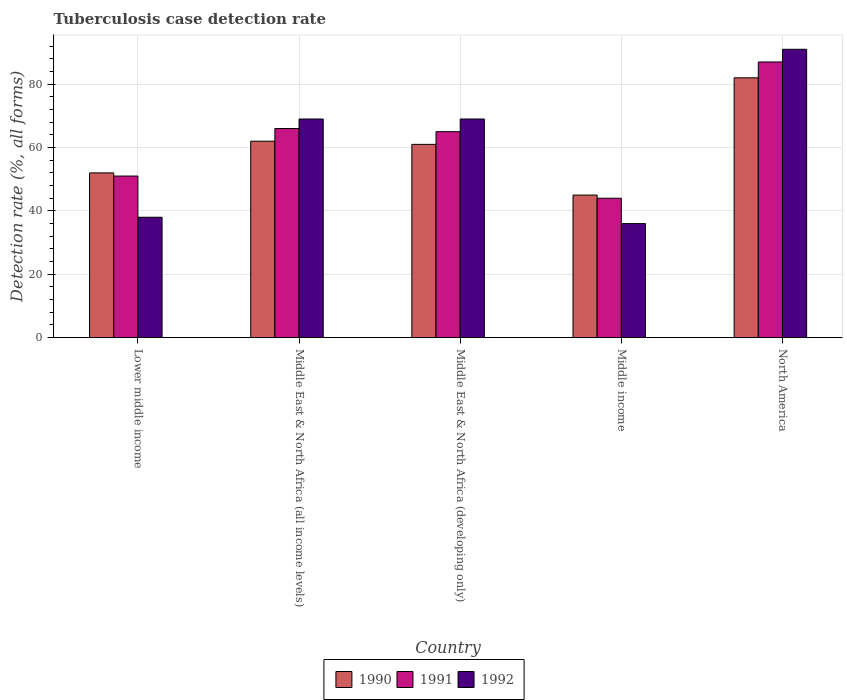How many different coloured bars are there?
Give a very brief answer. 3. How many groups of bars are there?
Your response must be concise. 5. Are the number of bars per tick equal to the number of legend labels?
Keep it short and to the point. Yes. Are the number of bars on each tick of the X-axis equal?
Your answer should be very brief. Yes. What is the label of the 4th group of bars from the left?
Your answer should be compact. Middle income. What is the tuberculosis case detection rate in in 1991 in Middle East & North Africa (all income levels)?
Give a very brief answer. 66. Across all countries, what is the minimum tuberculosis case detection rate in in 1992?
Provide a succinct answer. 36. In which country was the tuberculosis case detection rate in in 1990 minimum?
Your answer should be very brief. Middle income. What is the total tuberculosis case detection rate in in 1991 in the graph?
Provide a short and direct response. 313. What is the difference between the tuberculosis case detection rate in in 1992 in Lower middle income and the tuberculosis case detection rate in in 1990 in North America?
Your answer should be very brief. -44. What is the average tuberculosis case detection rate in in 1990 per country?
Your answer should be very brief. 60.4. In how many countries, is the tuberculosis case detection rate in in 1991 greater than 24 %?
Your answer should be very brief. 5. What is the ratio of the tuberculosis case detection rate in in 1990 in Middle income to that in North America?
Make the answer very short. 0.55. Is the tuberculosis case detection rate in in 1990 in Middle East & North Africa (all income levels) less than that in Middle income?
Keep it short and to the point. No. Is the difference between the tuberculosis case detection rate in in 1991 in Middle income and North America greater than the difference between the tuberculosis case detection rate in in 1990 in Middle income and North America?
Provide a short and direct response. No. What is the difference between the highest and the second highest tuberculosis case detection rate in in 1991?
Provide a short and direct response. -1. In how many countries, is the tuberculosis case detection rate in in 1991 greater than the average tuberculosis case detection rate in in 1991 taken over all countries?
Your answer should be compact. 3. Is it the case that in every country, the sum of the tuberculosis case detection rate in in 1991 and tuberculosis case detection rate in in 1990 is greater than the tuberculosis case detection rate in in 1992?
Offer a very short reply. Yes. How many bars are there?
Make the answer very short. 15. How many countries are there in the graph?
Provide a short and direct response. 5. What is the difference between two consecutive major ticks on the Y-axis?
Offer a very short reply. 20. Does the graph contain any zero values?
Offer a very short reply. No. Does the graph contain grids?
Provide a succinct answer. Yes. Where does the legend appear in the graph?
Give a very brief answer. Bottom center. How are the legend labels stacked?
Offer a terse response. Horizontal. What is the title of the graph?
Provide a short and direct response. Tuberculosis case detection rate. What is the label or title of the Y-axis?
Provide a succinct answer. Detection rate (%, all forms). What is the Detection rate (%, all forms) of 1992 in Lower middle income?
Ensure brevity in your answer.  38. What is the Detection rate (%, all forms) of 1991 in Middle East & North Africa (all income levels)?
Offer a terse response. 66. What is the Detection rate (%, all forms) in 1992 in Middle East & North Africa (developing only)?
Offer a very short reply. 69. What is the Detection rate (%, all forms) in 1991 in Middle income?
Offer a terse response. 44. What is the Detection rate (%, all forms) of 1992 in Middle income?
Provide a short and direct response. 36. What is the Detection rate (%, all forms) of 1991 in North America?
Ensure brevity in your answer.  87. What is the Detection rate (%, all forms) in 1992 in North America?
Provide a short and direct response. 91. Across all countries, what is the maximum Detection rate (%, all forms) in 1991?
Keep it short and to the point. 87. Across all countries, what is the maximum Detection rate (%, all forms) in 1992?
Keep it short and to the point. 91. What is the total Detection rate (%, all forms) of 1990 in the graph?
Provide a short and direct response. 302. What is the total Detection rate (%, all forms) of 1991 in the graph?
Offer a very short reply. 313. What is the total Detection rate (%, all forms) of 1992 in the graph?
Give a very brief answer. 303. What is the difference between the Detection rate (%, all forms) in 1991 in Lower middle income and that in Middle East & North Africa (all income levels)?
Keep it short and to the point. -15. What is the difference between the Detection rate (%, all forms) in 1992 in Lower middle income and that in Middle East & North Africa (all income levels)?
Give a very brief answer. -31. What is the difference between the Detection rate (%, all forms) of 1990 in Lower middle income and that in Middle East & North Africa (developing only)?
Your answer should be compact. -9. What is the difference between the Detection rate (%, all forms) in 1992 in Lower middle income and that in Middle East & North Africa (developing only)?
Make the answer very short. -31. What is the difference between the Detection rate (%, all forms) in 1991 in Lower middle income and that in Middle income?
Offer a very short reply. 7. What is the difference between the Detection rate (%, all forms) of 1991 in Lower middle income and that in North America?
Ensure brevity in your answer.  -36. What is the difference between the Detection rate (%, all forms) in 1992 in Lower middle income and that in North America?
Make the answer very short. -53. What is the difference between the Detection rate (%, all forms) of 1990 in Middle East & North Africa (all income levels) and that in Middle East & North Africa (developing only)?
Make the answer very short. 1. What is the difference between the Detection rate (%, all forms) of 1992 in Middle East & North Africa (all income levels) and that in Middle East & North Africa (developing only)?
Provide a short and direct response. 0. What is the difference between the Detection rate (%, all forms) of 1990 in Middle East & North Africa (developing only) and that in Middle income?
Make the answer very short. 16. What is the difference between the Detection rate (%, all forms) of 1991 in Middle East & North Africa (developing only) and that in Middle income?
Provide a succinct answer. 21. What is the difference between the Detection rate (%, all forms) in 1990 in Middle East & North Africa (developing only) and that in North America?
Provide a short and direct response. -21. What is the difference between the Detection rate (%, all forms) in 1991 in Middle East & North Africa (developing only) and that in North America?
Your answer should be compact. -22. What is the difference between the Detection rate (%, all forms) of 1992 in Middle East & North Africa (developing only) and that in North America?
Give a very brief answer. -22. What is the difference between the Detection rate (%, all forms) in 1990 in Middle income and that in North America?
Offer a terse response. -37. What is the difference between the Detection rate (%, all forms) in 1991 in Middle income and that in North America?
Your answer should be very brief. -43. What is the difference between the Detection rate (%, all forms) in 1992 in Middle income and that in North America?
Give a very brief answer. -55. What is the difference between the Detection rate (%, all forms) of 1990 in Lower middle income and the Detection rate (%, all forms) of 1991 in Middle East & North Africa (all income levels)?
Keep it short and to the point. -14. What is the difference between the Detection rate (%, all forms) of 1991 in Lower middle income and the Detection rate (%, all forms) of 1992 in Middle East & North Africa (all income levels)?
Give a very brief answer. -18. What is the difference between the Detection rate (%, all forms) of 1990 in Lower middle income and the Detection rate (%, all forms) of 1991 in Middle East & North Africa (developing only)?
Offer a terse response. -13. What is the difference between the Detection rate (%, all forms) of 1990 in Lower middle income and the Detection rate (%, all forms) of 1992 in Middle East & North Africa (developing only)?
Offer a terse response. -17. What is the difference between the Detection rate (%, all forms) of 1990 in Lower middle income and the Detection rate (%, all forms) of 1991 in Middle income?
Offer a terse response. 8. What is the difference between the Detection rate (%, all forms) of 1990 in Lower middle income and the Detection rate (%, all forms) of 1991 in North America?
Offer a terse response. -35. What is the difference between the Detection rate (%, all forms) in 1990 in Lower middle income and the Detection rate (%, all forms) in 1992 in North America?
Give a very brief answer. -39. What is the difference between the Detection rate (%, all forms) in 1991 in Lower middle income and the Detection rate (%, all forms) in 1992 in North America?
Your response must be concise. -40. What is the difference between the Detection rate (%, all forms) of 1990 in Middle East & North Africa (all income levels) and the Detection rate (%, all forms) of 1992 in Middle East & North Africa (developing only)?
Keep it short and to the point. -7. What is the difference between the Detection rate (%, all forms) in 1991 in Middle East & North Africa (all income levels) and the Detection rate (%, all forms) in 1992 in Middle East & North Africa (developing only)?
Your answer should be very brief. -3. What is the difference between the Detection rate (%, all forms) of 1990 in Middle East & North Africa (all income levels) and the Detection rate (%, all forms) of 1992 in North America?
Offer a very short reply. -29. What is the difference between the Detection rate (%, all forms) of 1991 in Middle East & North Africa (developing only) and the Detection rate (%, all forms) of 1992 in Middle income?
Your answer should be very brief. 29. What is the difference between the Detection rate (%, all forms) in 1990 in Middle East & North Africa (developing only) and the Detection rate (%, all forms) in 1991 in North America?
Make the answer very short. -26. What is the difference between the Detection rate (%, all forms) in 1991 in Middle East & North Africa (developing only) and the Detection rate (%, all forms) in 1992 in North America?
Give a very brief answer. -26. What is the difference between the Detection rate (%, all forms) in 1990 in Middle income and the Detection rate (%, all forms) in 1991 in North America?
Provide a short and direct response. -42. What is the difference between the Detection rate (%, all forms) in 1990 in Middle income and the Detection rate (%, all forms) in 1992 in North America?
Your answer should be very brief. -46. What is the difference between the Detection rate (%, all forms) in 1991 in Middle income and the Detection rate (%, all forms) in 1992 in North America?
Ensure brevity in your answer.  -47. What is the average Detection rate (%, all forms) of 1990 per country?
Provide a short and direct response. 60.4. What is the average Detection rate (%, all forms) in 1991 per country?
Offer a terse response. 62.6. What is the average Detection rate (%, all forms) of 1992 per country?
Your answer should be compact. 60.6. What is the difference between the Detection rate (%, all forms) in 1990 and Detection rate (%, all forms) in 1991 in Lower middle income?
Keep it short and to the point. 1. What is the difference between the Detection rate (%, all forms) in 1990 and Detection rate (%, all forms) in 1992 in Lower middle income?
Your answer should be very brief. 14. What is the difference between the Detection rate (%, all forms) in 1991 and Detection rate (%, all forms) in 1992 in Middle East & North Africa (all income levels)?
Your response must be concise. -3. What is the difference between the Detection rate (%, all forms) in 1990 and Detection rate (%, all forms) in 1991 in Middle East & North Africa (developing only)?
Keep it short and to the point. -4. What is the difference between the Detection rate (%, all forms) in 1991 and Detection rate (%, all forms) in 1992 in Middle income?
Ensure brevity in your answer.  8. What is the difference between the Detection rate (%, all forms) of 1990 and Detection rate (%, all forms) of 1991 in North America?
Your answer should be compact. -5. What is the difference between the Detection rate (%, all forms) of 1990 and Detection rate (%, all forms) of 1992 in North America?
Ensure brevity in your answer.  -9. What is the difference between the Detection rate (%, all forms) of 1991 and Detection rate (%, all forms) of 1992 in North America?
Provide a succinct answer. -4. What is the ratio of the Detection rate (%, all forms) of 1990 in Lower middle income to that in Middle East & North Africa (all income levels)?
Provide a succinct answer. 0.84. What is the ratio of the Detection rate (%, all forms) of 1991 in Lower middle income to that in Middle East & North Africa (all income levels)?
Offer a very short reply. 0.77. What is the ratio of the Detection rate (%, all forms) in 1992 in Lower middle income to that in Middle East & North Africa (all income levels)?
Your answer should be compact. 0.55. What is the ratio of the Detection rate (%, all forms) of 1990 in Lower middle income to that in Middle East & North Africa (developing only)?
Make the answer very short. 0.85. What is the ratio of the Detection rate (%, all forms) of 1991 in Lower middle income to that in Middle East & North Africa (developing only)?
Ensure brevity in your answer.  0.78. What is the ratio of the Detection rate (%, all forms) of 1992 in Lower middle income to that in Middle East & North Africa (developing only)?
Your answer should be compact. 0.55. What is the ratio of the Detection rate (%, all forms) in 1990 in Lower middle income to that in Middle income?
Provide a short and direct response. 1.16. What is the ratio of the Detection rate (%, all forms) of 1991 in Lower middle income to that in Middle income?
Provide a short and direct response. 1.16. What is the ratio of the Detection rate (%, all forms) in 1992 in Lower middle income to that in Middle income?
Provide a short and direct response. 1.06. What is the ratio of the Detection rate (%, all forms) of 1990 in Lower middle income to that in North America?
Provide a short and direct response. 0.63. What is the ratio of the Detection rate (%, all forms) in 1991 in Lower middle income to that in North America?
Give a very brief answer. 0.59. What is the ratio of the Detection rate (%, all forms) in 1992 in Lower middle income to that in North America?
Offer a very short reply. 0.42. What is the ratio of the Detection rate (%, all forms) of 1990 in Middle East & North Africa (all income levels) to that in Middle East & North Africa (developing only)?
Make the answer very short. 1.02. What is the ratio of the Detection rate (%, all forms) in 1991 in Middle East & North Africa (all income levels) to that in Middle East & North Africa (developing only)?
Ensure brevity in your answer.  1.02. What is the ratio of the Detection rate (%, all forms) of 1992 in Middle East & North Africa (all income levels) to that in Middle East & North Africa (developing only)?
Keep it short and to the point. 1. What is the ratio of the Detection rate (%, all forms) of 1990 in Middle East & North Africa (all income levels) to that in Middle income?
Keep it short and to the point. 1.38. What is the ratio of the Detection rate (%, all forms) in 1991 in Middle East & North Africa (all income levels) to that in Middle income?
Offer a very short reply. 1.5. What is the ratio of the Detection rate (%, all forms) in 1992 in Middle East & North Africa (all income levels) to that in Middle income?
Give a very brief answer. 1.92. What is the ratio of the Detection rate (%, all forms) in 1990 in Middle East & North Africa (all income levels) to that in North America?
Your answer should be compact. 0.76. What is the ratio of the Detection rate (%, all forms) in 1991 in Middle East & North Africa (all income levels) to that in North America?
Your answer should be very brief. 0.76. What is the ratio of the Detection rate (%, all forms) of 1992 in Middle East & North Africa (all income levels) to that in North America?
Give a very brief answer. 0.76. What is the ratio of the Detection rate (%, all forms) in 1990 in Middle East & North Africa (developing only) to that in Middle income?
Give a very brief answer. 1.36. What is the ratio of the Detection rate (%, all forms) in 1991 in Middle East & North Africa (developing only) to that in Middle income?
Ensure brevity in your answer.  1.48. What is the ratio of the Detection rate (%, all forms) in 1992 in Middle East & North Africa (developing only) to that in Middle income?
Keep it short and to the point. 1.92. What is the ratio of the Detection rate (%, all forms) of 1990 in Middle East & North Africa (developing only) to that in North America?
Your response must be concise. 0.74. What is the ratio of the Detection rate (%, all forms) in 1991 in Middle East & North Africa (developing only) to that in North America?
Your response must be concise. 0.75. What is the ratio of the Detection rate (%, all forms) of 1992 in Middle East & North Africa (developing only) to that in North America?
Provide a succinct answer. 0.76. What is the ratio of the Detection rate (%, all forms) of 1990 in Middle income to that in North America?
Provide a succinct answer. 0.55. What is the ratio of the Detection rate (%, all forms) in 1991 in Middle income to that in North America?
Make the answer very short. 0.51. What is the ratio of the Detection rate (%, all forms) of 1992 in Middle income to that in North America?
Offer a terse response. 0.4. What is the difference between the highest and the second highest Detection rate (%, all forms) of 1990?
Give a very brief answer. 20. What is the difference between the highest and the lowest Detection rate (%, all forms) in 1990?
Your answer should be compact. 37. What is the difference between the highest and the lowest Detection rate (%, all forms) in 1992?
Keep it short and to the point. 55. 